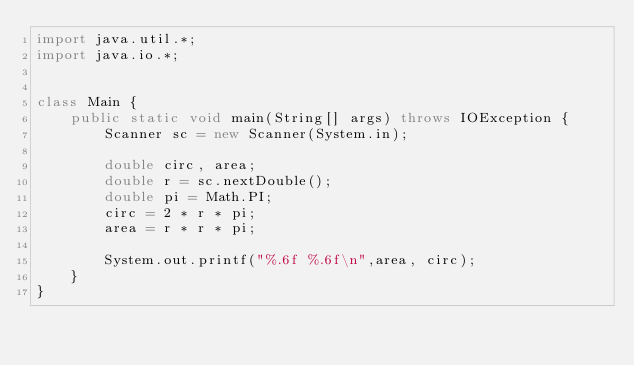Convert code to text. <code><loc_0><loc_0><loc_500><loc_500><_Java_>import java.util.*;
import java.io.*;


class Main {
    public static void main(String[] args) throws IOException {
        Scanner sc = new Scanner(System.in);
        
        double circ, area;
        double r = sc.nextDouble();
        double pi = Math.PI;
        circ = 2 * r * pi;
        area = r * r * pi;
        
        System.out.printf("%.6f %.6f\n",area, circ);
    }
}</code> 